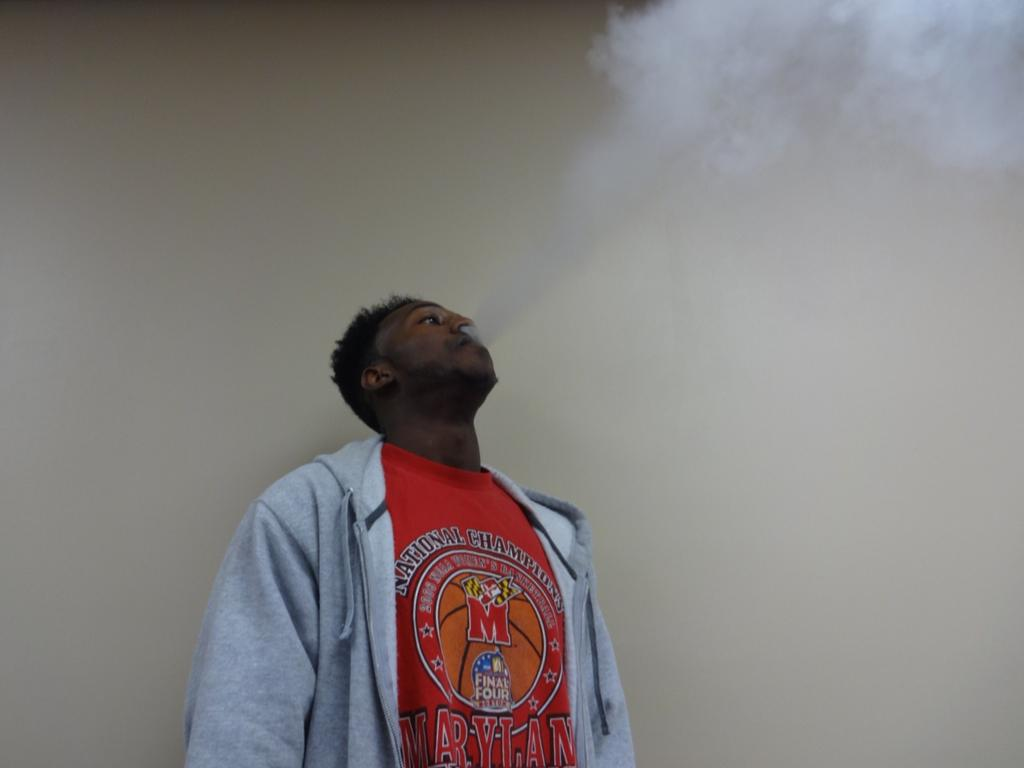Provide a one-sentence caption for the provided image. A man smokes while wearing a red final four shirt. 